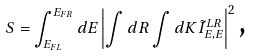<formula> <loc_0><loc_0><loc_500><loc_500>S = \int _ { E _ { F L } } ^ { E _ { F R } } d E \left | \int d R \int d K \tilde { I } _ { E , E } ^ { L R } \right | ^ { 2 } \text {,}</formula> 